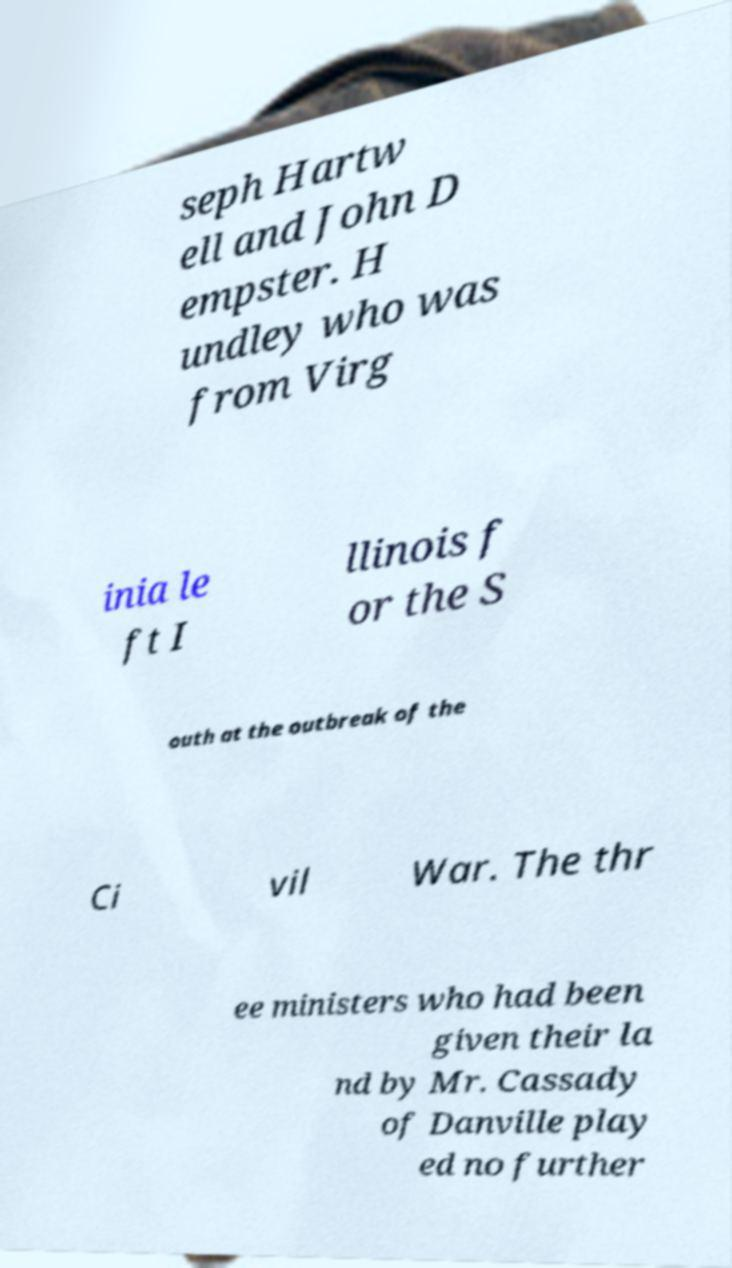Could you extract and type out the text from this image? seph Hartw ell and John D empster. H undley who was from Virg inia le ft I llinois f or the S outh at the outbreak of the Ci vil War. The thr ee ministers who had been given their la nd by Mr. Cassady of Danville play ed no further 